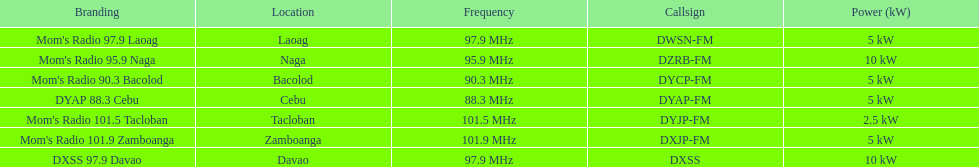What radio possesses the greatest mhz? Mom's Radio 101.9 Zamboanga. 